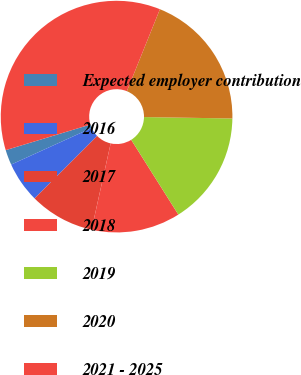Convert chart. <chart><loc_0><loc_0><loc_500><loc_500><pie_chart><fcel>Expected employer contribution<fcel>2016<fcel>2017<fcel>2018<fcel>2019<fcel>2020<fcel>2021 - 2025<nl><fcel>2.12%<fcel>5.69%<fcel>9.05%<fcel>12.42%<fcel>15.79%<fcel>19.15%<fcel>35.78%<nl></chart> 